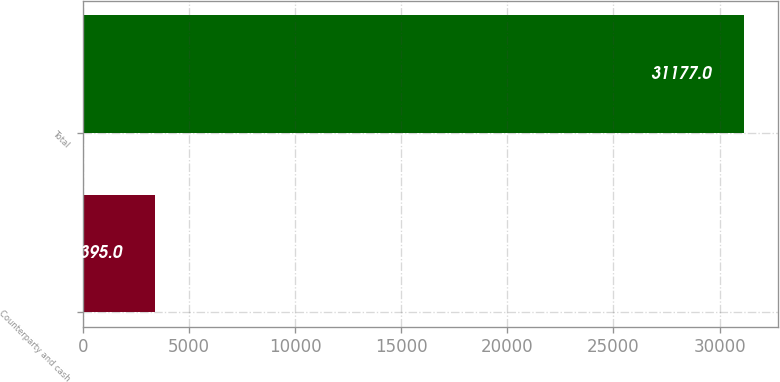Convert chart to OTSL. <chart><loc_0><loc_0><loc_500><loc_500><bar_chart><fcel>Counterparty and cash<fcel>Total<nl><fcel>3395<fcel>31177<nl></chart> 